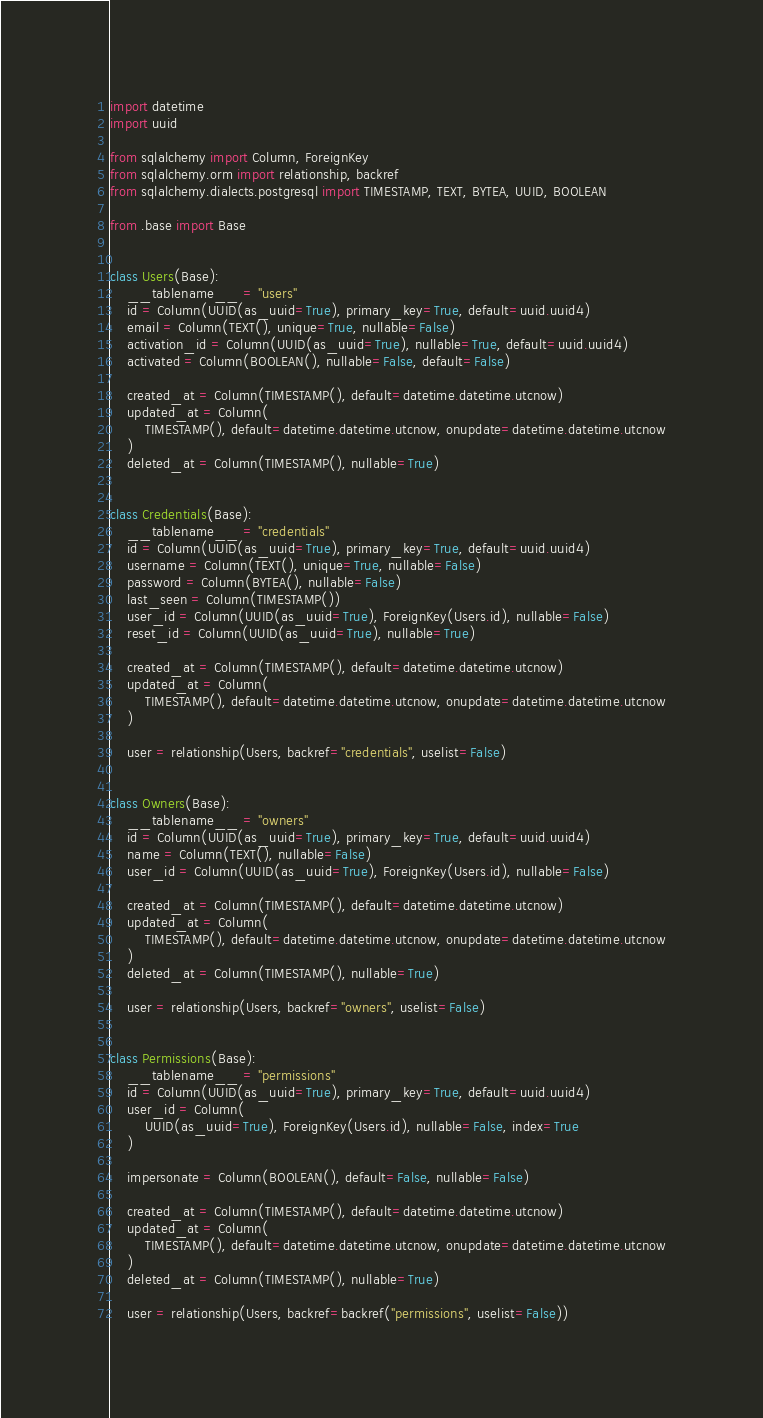<code> <loc_0><loc_0><loc_500><loc_500><_Python_>import datetime
import uuid

from sqlalchemy import Column, ForeignKey
from sqlalchemy.orm import relationship, backref
from sqlalchemy.dialects.postgresql import TIMESTAMP, TEXT, BYTEA, UUID, BOOLEAN

from .base import Base


class Users(Base):
    __tablename__ = "users"
    id = Column(UUID(as_uuid=True), primary_key=True, default=uuid.uuid4)
    email = Column(TEXT(), unique=True, nullable=False)
    activation_id = Column(UUID(as_uuid=True), nullable=True, default=uuid.uuid4)
    activated = Column(BOOLEAN(), nullable=False, default=False)

    created_at = Column(TIMESTAMP(), default=datetime.datetime.utcnow)
    updated_at = Column(
        TIMESTAMP(), default=datetime.datetime.utcnow, onupdate=datetime.datetime.utcnow
    )
    deleted_at = Column(TIMESTAMP(), nullable=True)


class Credentials(Base):
    __tablename__ = "credentials"
    id = Column(UUID(as_uuid=True), primary_key=True, default=uuid.uuid4)
    username = Column(TEXT(), unique=True, nullable=False)
    password = Column(BYTEA(), nullable=False)
    last_seen = Column(TIMESTAMP())
    user_id = Column(UUID(as_uuid=True), ForeignKey(Users.id), nullable=False)
    reset_id = Column(UUID(as_uuid=True), nullable=True)

    created_at = Column(TIMESTAMP(), default=datetime.datetime.utcnow)
    updated_at = Column(
        TIMESTAMP(), default=datetime.datetime.utcnow, onupdate=datetime.datetime.utcnow
    )

    user = relationship(Users, backref="credentials", uselist=False)


class Owners(Base):
    __tablename__ = "owners"
    id = Column(UUID(as_uuid=True), primary_key=True, default=uuid.uuid4)
    name = Column(TEXT(), nullable=False)
    user_id = Column(UUID(as_uuid=True), ForeignKey(Users.id), nullable=False)

    created_at = Column(TIMESTAMP(), default=datetime.datetime.utcnow)
    updated_at = Column(
        TIMESTAMP(), default=datetime.datetime.utcnow, onupdate=datetime.datetime.utcnow
    )
    deleted_at = Column(TIMESTAMP(), nullable=True)

    user = relationship(Users, backref="owners", uselist=False)


class Permissions(Base):
    __tablename__ = "permissions"
    id = Column(UUID(as_uuid=True), primary_key=True, default=uuid.uuid4)
    user_id = Column(
        UUID(as_uuid=True), ForeignKey(Users.id), nullable=False, index=True
    )

    impersonate = Column(BOOLEAN(), default=False, nullable=False)

    created_at = Column(TIMESTAMP(), default=datetime.datetime.utcnow)
    updated_at = Column(
        TIMESTAMP(), default=datetime.datetime.utcnow, onupdate=datetime.datetime.utcnow
    )
    deleted_at = Column(TIMESTAMP(), nullable=True)

    user = relationship(Users, backref=backref("permissions", uselist=False))
</code> 